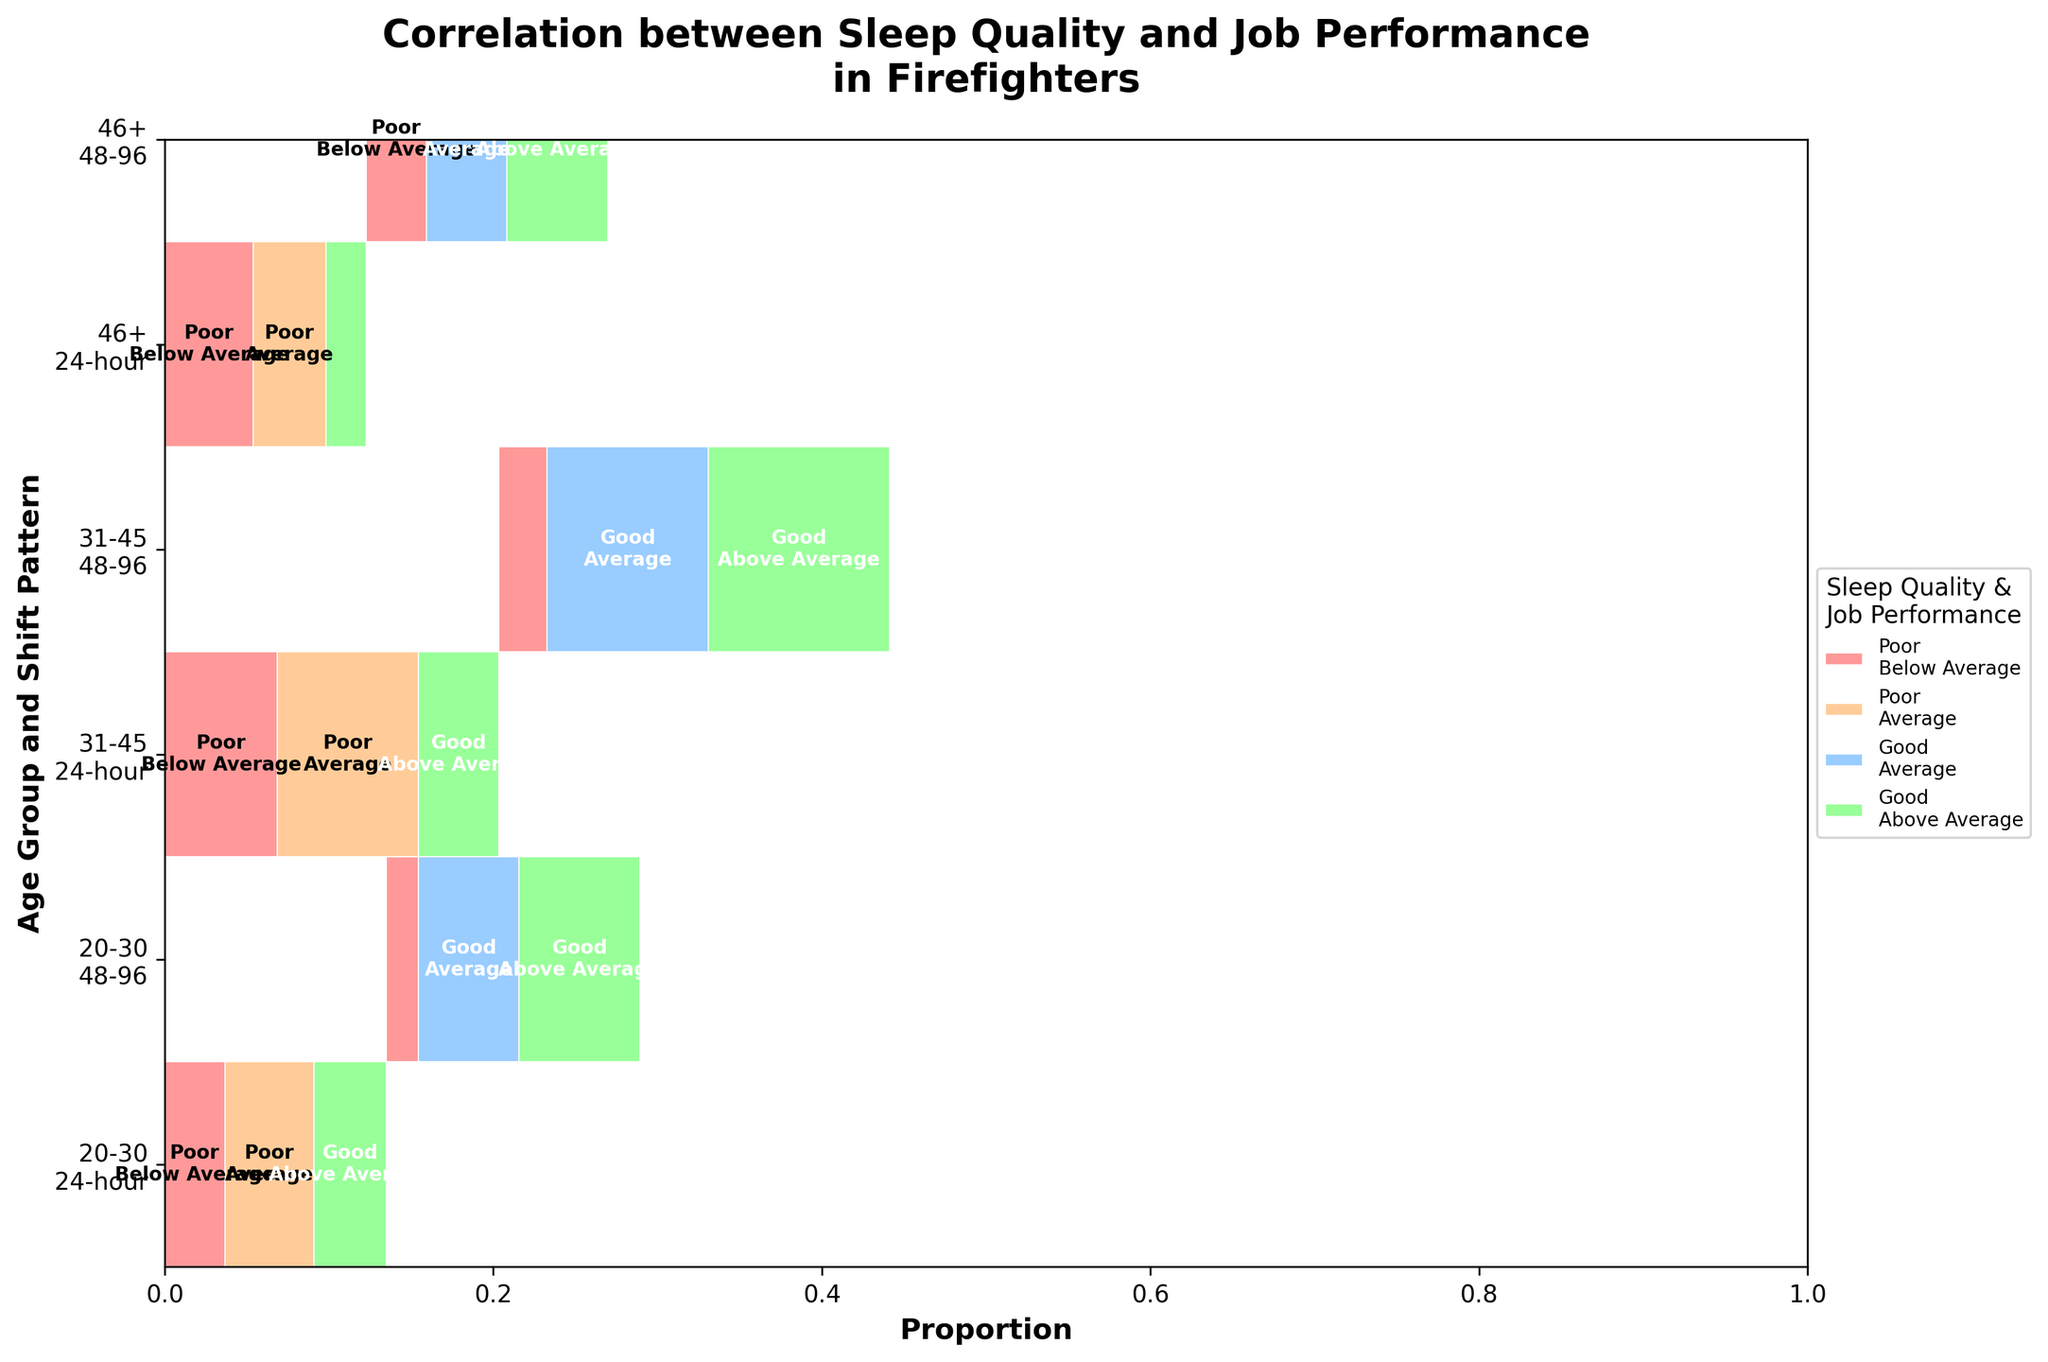How is the correlation between sleep quality and job performance depicted in firefighters? The mosaic plot uses color-coded rectangles to represent different combinations of sleep quality and job performance, providing a visual indication of the proportion of each combination within different age and shift patterns.
Answer: Color-coded rectangles What is the title of the mosaic plot? The title of the mosaic plot is mentioned at the top of the figure. It reads "Correlation between Sleep Quality and Job Performance in Firefighters."
Answer: Correlation between Sleep Quality and Job Performance in Firefighters How does sleep quality correlate with job performance in young firefighters (age 20-30) on a 48-96 shift pattern? By examining the plot, we notice that good sleep quality is strongly associated with above-average job performance, as indicated by the size of the green rectangles. Poor sleep quality does not dominate the visual space, suggesting lower job performance with poor sleep.
Answer: Good sleep, above-average performance Which age group and shift pattern combination has the highest proportion of firefighters with poor sleep quality and average job performance? The plot shows that the age group 31-45 with a 24-hour shift pattern has the largest orange segment, indicating this combination has the highest proportion of firefighters with poor sleep quality resulting in average job performance.
Answer: Age 31-45, 24-hour shift Is there any age group where poor sleep quality and below-average job performance are more prevalent? Looking at the red rectangles in the plot, the age group 31-45 with a 24-hour shift pattern has noticeable coverage of poor sleep quality correlating with below-average job performance.
Answer: Age 31-45, 24-hour shift Compare the job performance of firefighters aged 46+ in different shift patterns with good sleep quality. For firefighters aged 46+ with good sleep quality, the visual size of blue and green rectangles indicates both average and above-average job performance. There is a notable proportion in the 48-96 shift pattern compared to the 24-hour shift pattern.
Answer: Better performance in 48-96 shift Which shift pattern seems to result in better job performance across all age groups with good sleep quality? The green rectangles associated with good sleep quality and above-average job performance are larger for the 48-96 shift pattern across all age groups, indicating better performance in these schedule combinations.
Answer: 48-96 shift pattern How do different sleep qualities impact job performance for firefighters aged 31-45 on a 48-96 shift pattern? Examining the patterns, optimal job performance (green segments) predominates with good sleep quality, while poor sleep reveals scant below-average performance, indicating job performance improves markedly with better sleep.
Answer: Better with good sleep What is the most common job performance for young firefighters with good sleep quality on a 24-hour shift? The figure indicates that the majority of young firefighters (20-30) with good sleep quality in a 24-hour shift have above-average job performance, represented by the green rectangles.
Answer: Above average How is sleep quality distributed among different shift patterns for firefighters aged 46+? By observing the ratio of red, orange, blue, and green rectangles for the 46+ age group across shift patterns, we see more mixed sleep quality in 24-hour shifts, with better sleep quality in 48-96 shifts having predominant blue and green representation.
Answer: More mixed in 24-hour, better in 48-96 